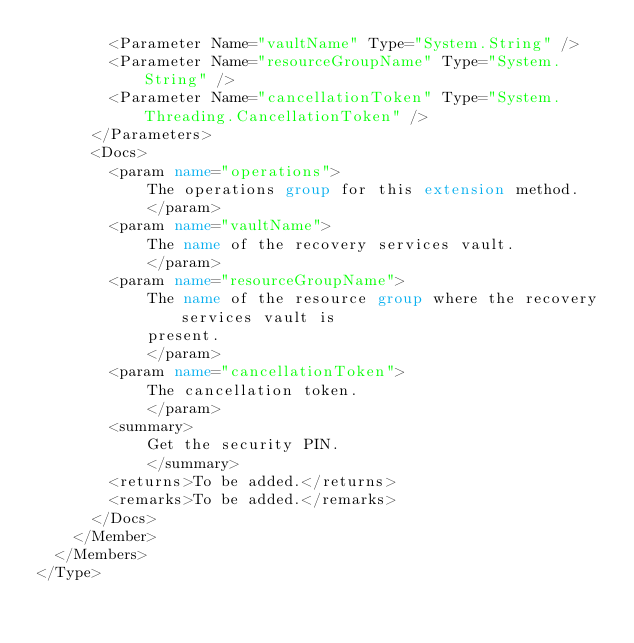<code> <loc_0><loc_0><loc_500><loc_500><_XML_>        <Parameter Name="vaultName" Type="System.String" />
        <Parameter Name="resourceGroupName" Type="System.String" />
        <Parameter Name="cancellationToken" Type="System.Threading.CancellationToken" />
      </Parameters>
      <Docs>
        <param name="operations">
            The operations group for this extension method.
            </param>
        <param name="vaultName">
            The name of the recovery services vault.
            </param>
        <param name="resourceGroupName">
            The name of the resource group where the recovery services vault is
            present.
            </param>
        <param name="cancellationToken">
            The cancellation token.
            </param>
        <summary>
            Get the security PIN.
            </summary>
        <returns>To be added.</returns>
        <remarks>To be added.</remarks>
      </Docs>
    </Member>
  </Members>
</Type>
</code> 